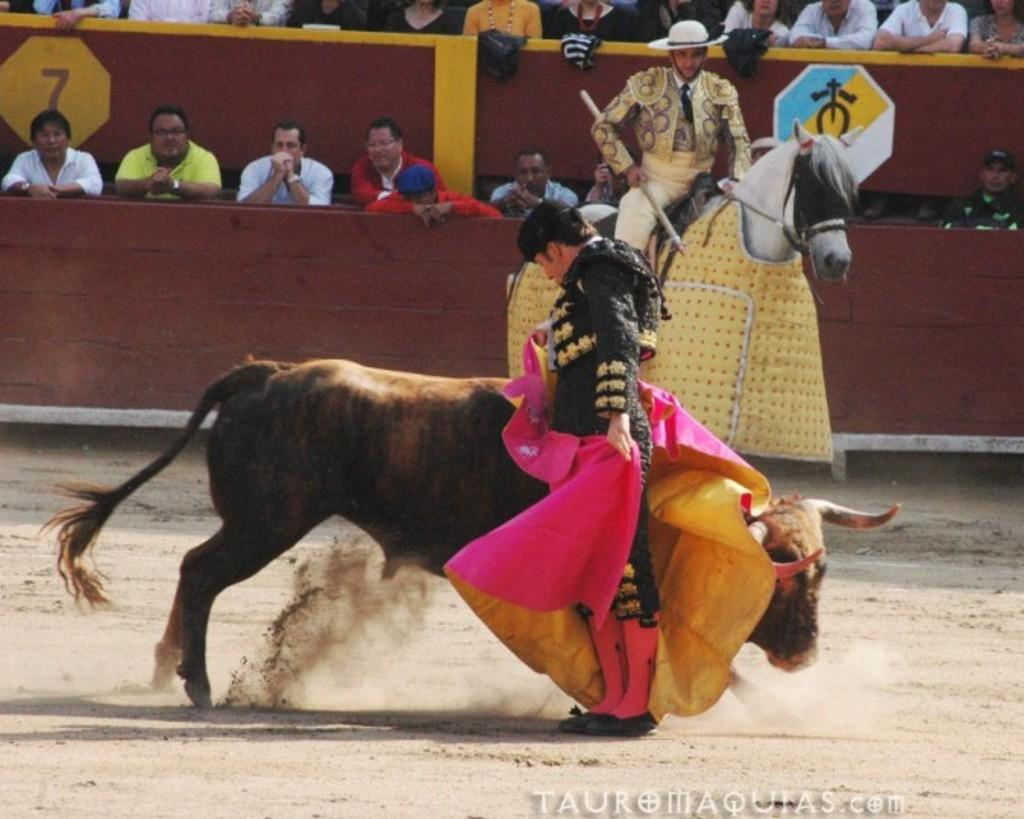What animal is the main subject of the image? There is a bull in the image. Who is standing beside the bull? There is a person with a cloth standing beside the bull. What other animal is present in the image? There is a person sitting on a horse in the image. What can be seen in the background of the image? There are people watching the scene in the background. What type of music is being played during the competition in the image? There is no competition or music present in the image; it features a bull, a person with a cloth, a person on a horse, and people watching the scene in the background. 